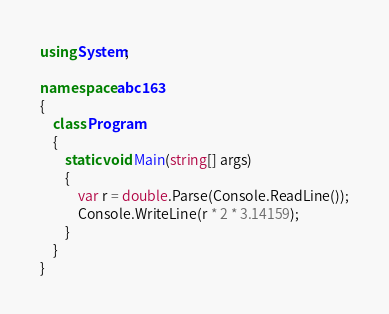<code> <loc_0><loc_0><loc_500><loc_500><_C#_>using System;

namespace abc163
{
    class Program
    {
        static void Main(string[] args)
        {
            var r = double.Parse(Console.ReadLine());
            Console.WriteLine(r * 2 * 3.14159);
        }
    }
}
</code> 